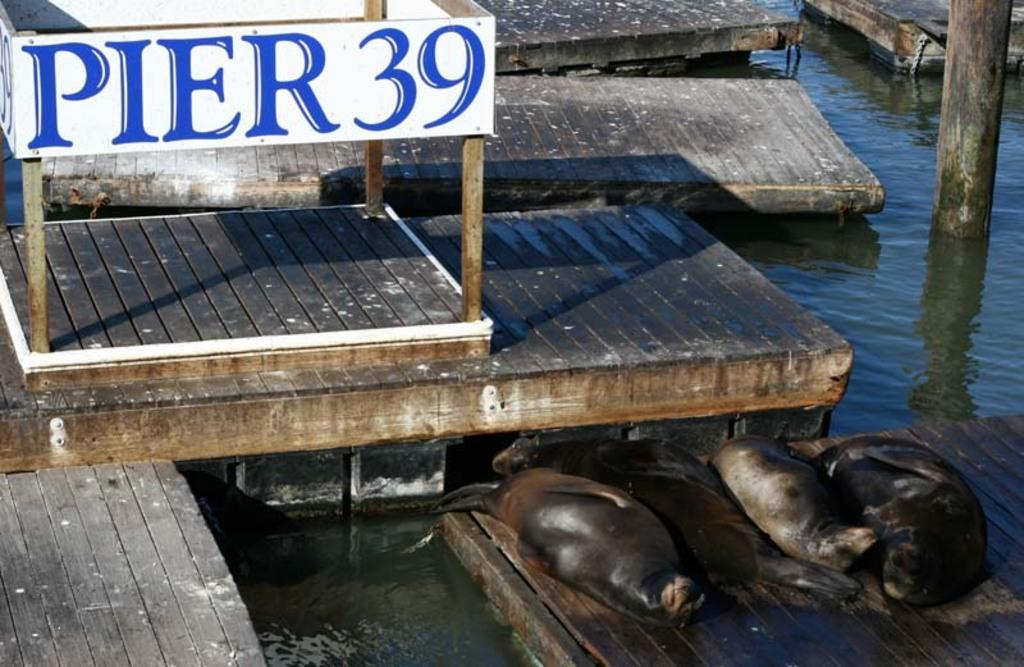What type of material is used to construct the objects in the image? The objects in the image are made of wood, as seen in the wooden bricks and pole. Where are the wooden bricks and pole located? They are on a river in the image. What additional feature can be seen on the wooden bricks? Some of the wooden bricks have seals on them. What kind of signage is present in the image? There is a banner with text in the image. What type of substance is being used to fill the gaps between the wooden bricks in the image? There is no visible substance being used to fill the gaps between the wooden bricks in the image. 